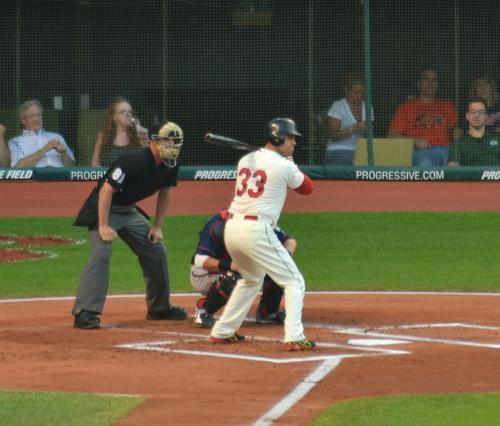How many people holding a bat?
Give a very brief answer. 1. 